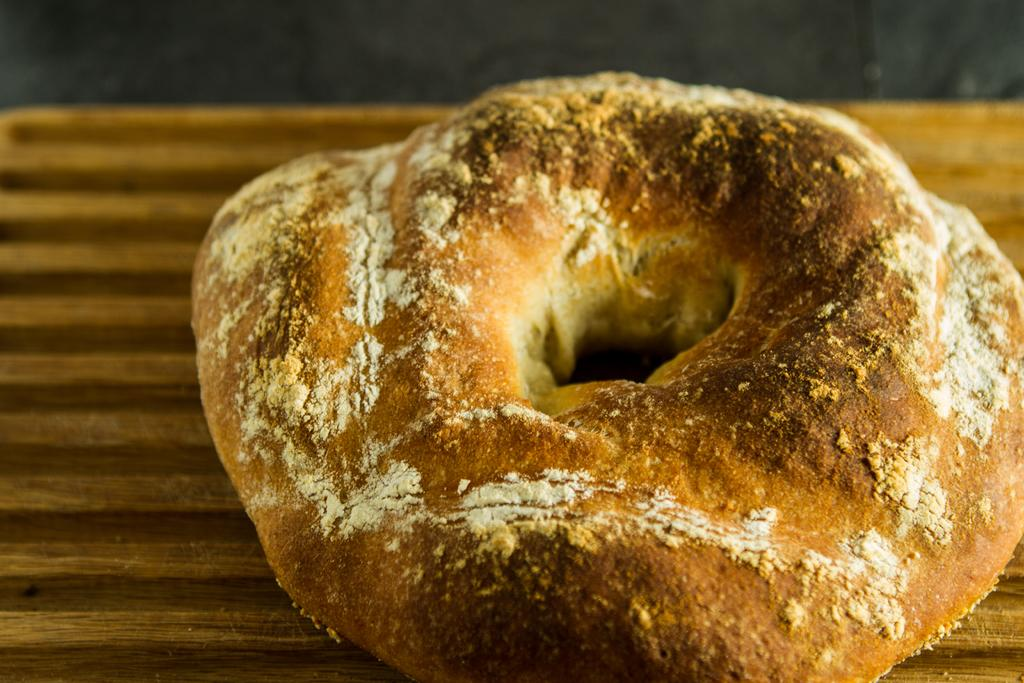What is the main object in the image? There is a brown color board in the image. What is on the brown color board? Food is present on the board. Can you describe the color of the food on the board? The food has brown and white colors. How much payment is required for the oatmeal in the image? There is no oatmeal present in the image, and therefore no payment is required. 